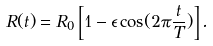<formula> <loc_0><loc_0><loc_500><loc_500>R ( t ) = R _ { 0 } \left [ 1 - \epsilon \cos ( 2 \pi \frac { t } { T } ) \right ] .</formula> 